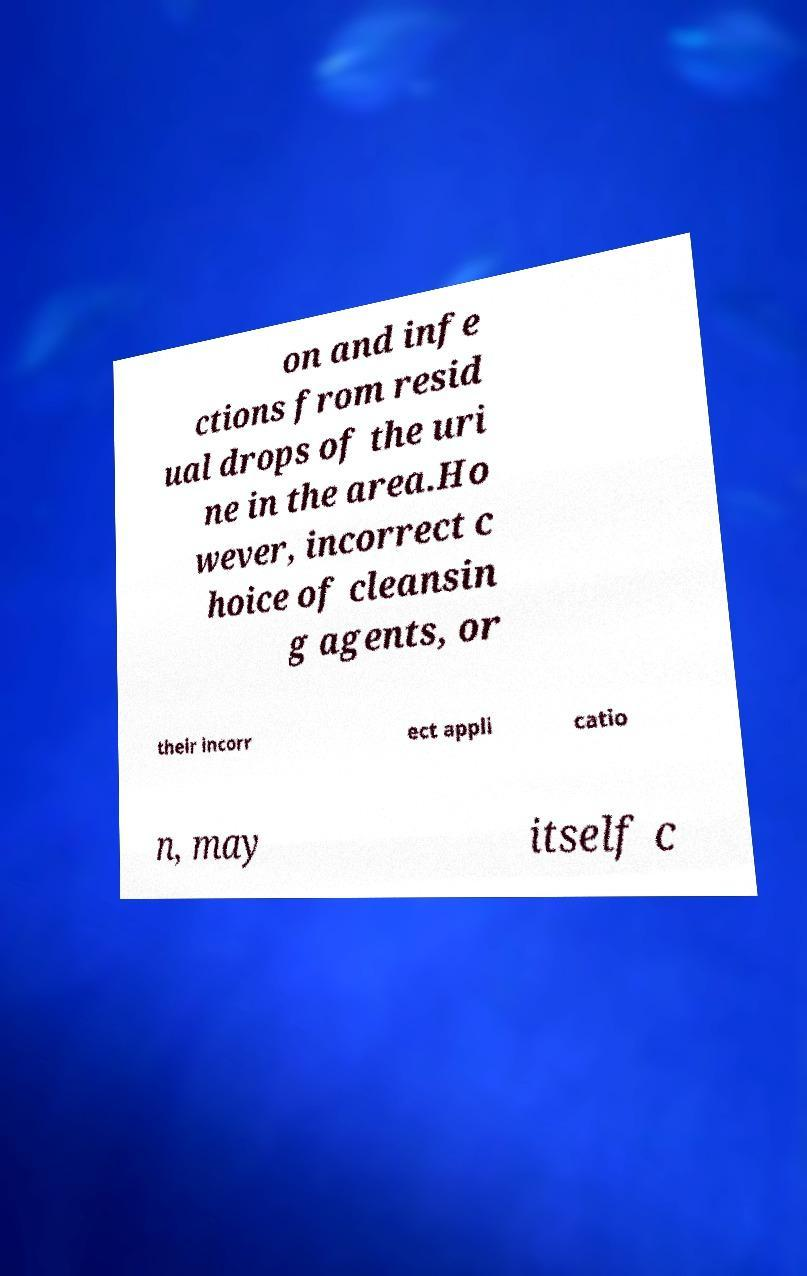Please identify and transcribe the text found in this image. on and infe ctions from resid ual drops of the uri ne in the area.Ho wever, incorrect c hoice of cleansin g agents, or their incorr ect appli catio n, may itself c 